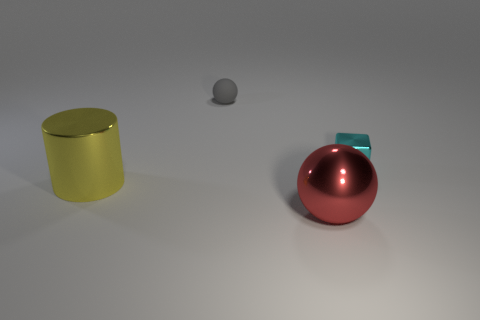Add 1 large red shiny things. How many objects exist? 5 Subtract all blocks. How many objects are left? 3 Add 1 green blocks. How many green blocks exist? 1 Subtract 0 purple cylinders. How many objects are left? 4 Subtract all small cyan blocks. Subtract all matte balls. How many objects are left? 2 Add 2 small matte objects. How many small matte objects are left? 3 